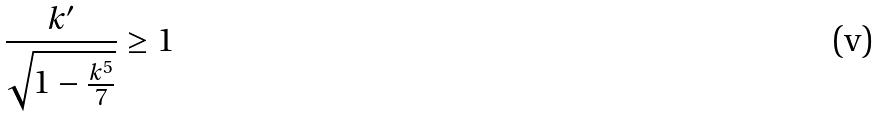Convert formula to latex. <formula><loc_0><loc_0><loc_500><loc_500>\frac { k ^ { \prime } } { \sqrt { 1 - \frac { k ^ { 5 } } { 7 } } } \geq 1</formula> 